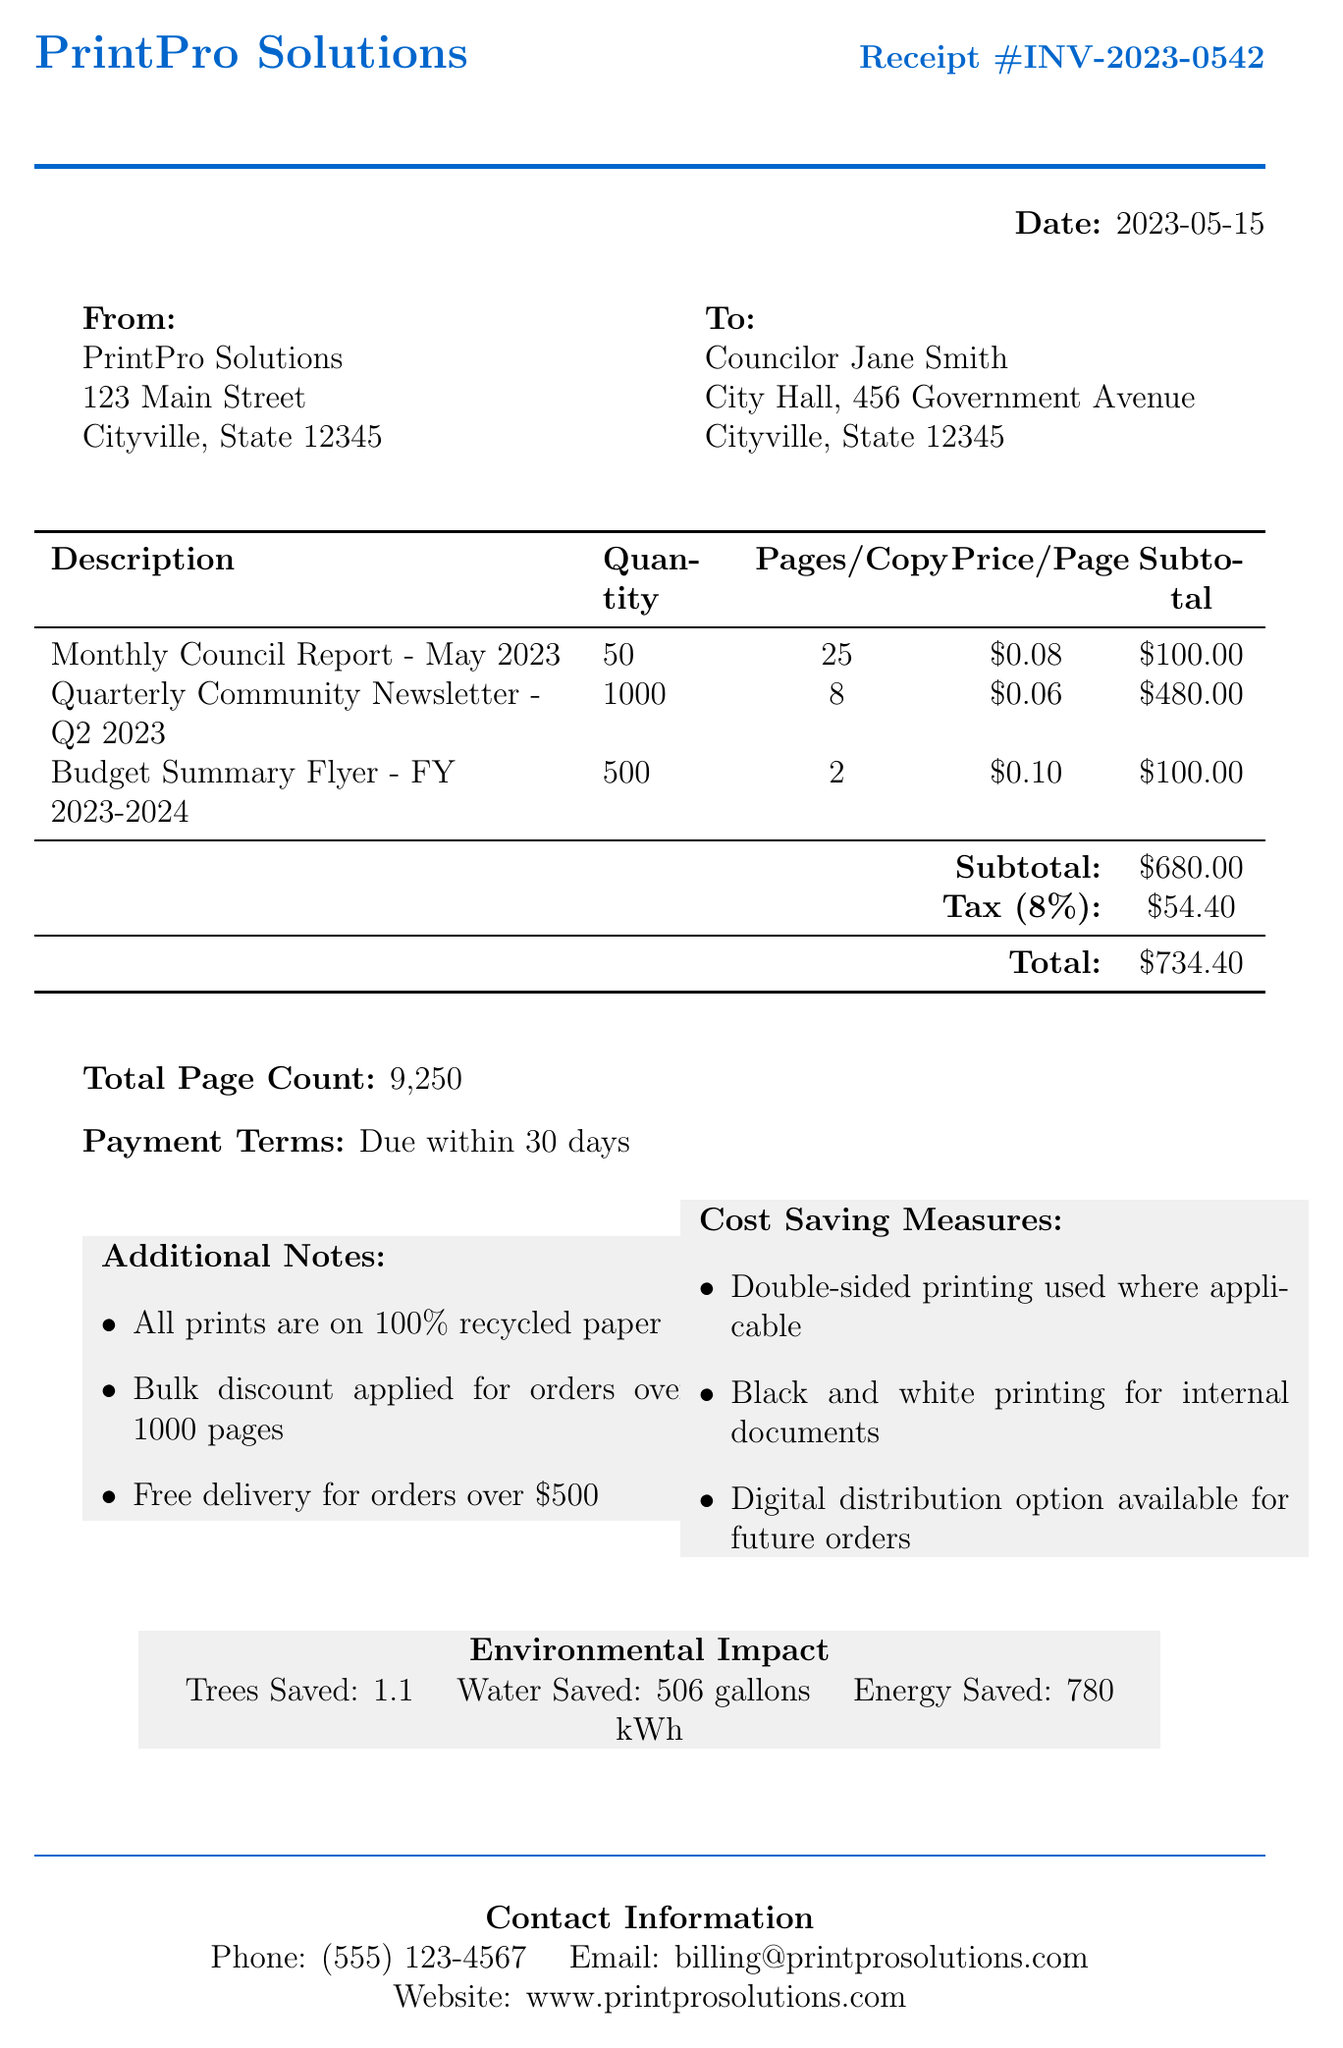What is the receipt number? The receipt number is specified at the top of the document as INV-2023-0542.
Answer: INV-2023-0542 What is the total amount charged? The total amount charged is the final sum listed in the receipt, which includes subtotals and tax.
Answer: 734.40 How many copies of the Quarterly Community Newsletter were printed? The quantity of the Quarterly Community Newsletter is detailed under its description, which states 1000 copies.
Answer: 1000 What is the price per page for the Budget Summary Flyer? The price per page for the Budget Summary Flyer is explicitly listed as $0.10.
Answer: 0.10 How many pages are in the Monthly Council Report? The Monthly Council Report contains 25 pages per copy, as listed in the receipt.
Answer: 25 What is the subtotal for the printing services? The subtotal is found in the receipt and represents the total before tax, calculated as $680.00.
Answer: 680.00 What cost-saving measure involves printing style? The cost-saving measure related to printing style is mentioned as double-sided printing used where applicable.
Answer: Double-sided printing What environmental impact is mentioned regarding trees? The document specifies an environmental impact related to trees saved, which is listed as 1.1.
Answer: 1.1 What payment terms are set for this invoice? The payment terms are clearly stated as due within 30 days shown in the receipt.
Answer: Due within 30 days 